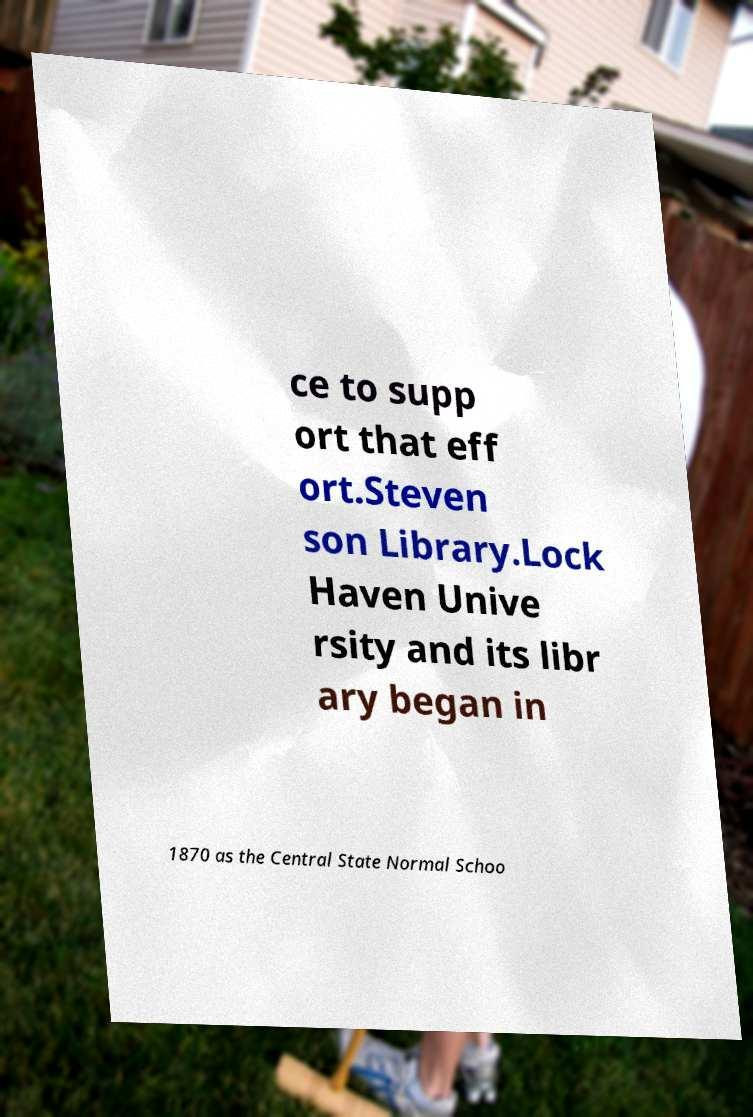For documentation purposes, I need the text within this image transcribed. Could you provide that? ce to supp ort that eff ort.Steven son Library.Lock Haven Unive rsity and its libr ary began in 1870 as the Central State Normal Schoo 